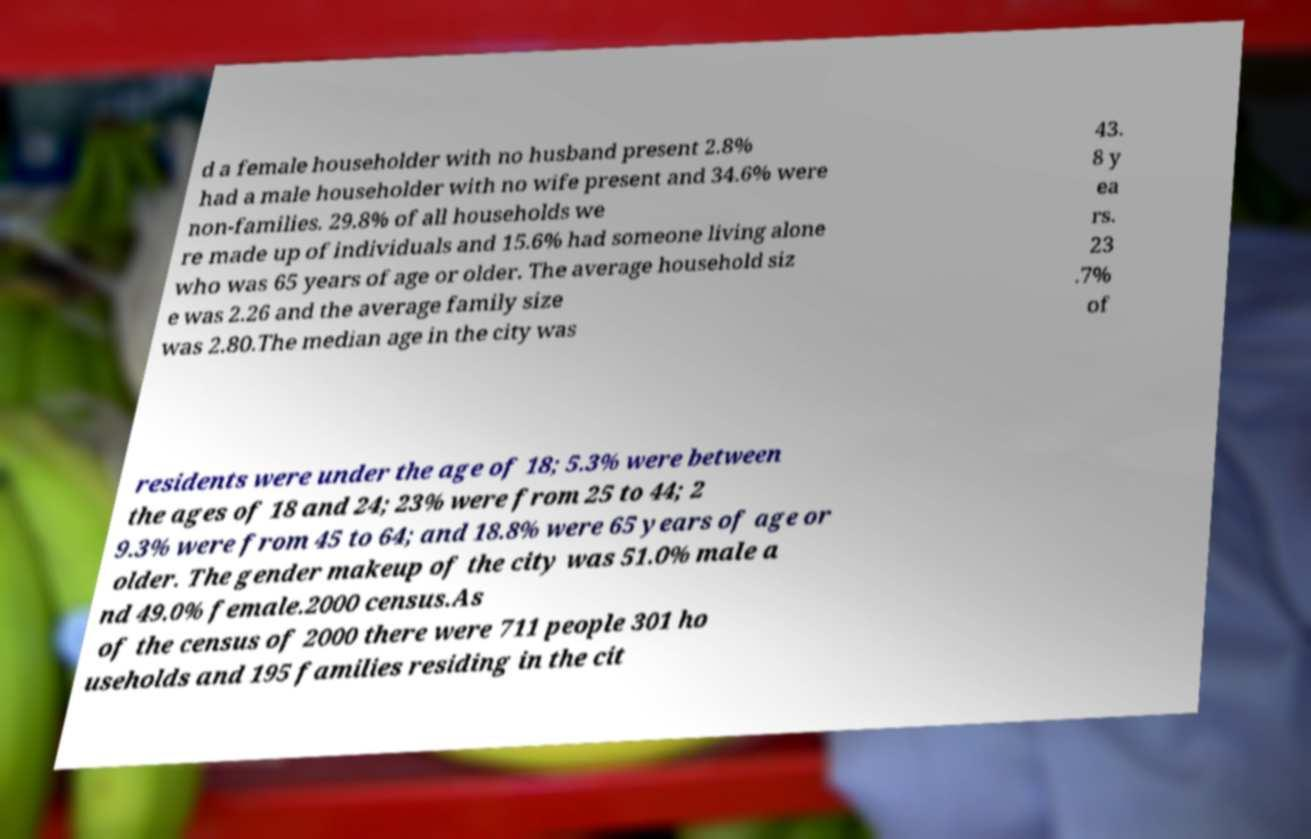Please identify and transcribe the text found in this image. d a female householder with no husband present 2.8% had a male householder with no wife present and 34.6% were non-families. 29.8% of all households we re made up of individuals and 15.6% had someone living alone who was 65 years of age or older. The average household siz e was 2.26 and the average family size was 2.80.The median age in the city was 43. 8 y ea rs. 23 .7% of residents were under the age of 18; 5.3% were between the ages of 18 and 24; 23% were from 25 to 44; 2 9.3% were from 45 to 64; and 18.8% were 65 years of age or older. The gender makeup of the city was 51.0% male a nd 49.0% female.2000 census.As of the census of 2000 there were 711 people 301 ho useholds and 195 families residing in the cit 